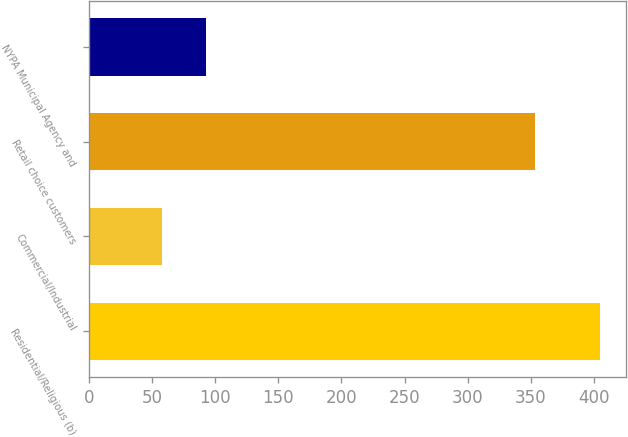Convert chart to OTSL. <chart><loc_0><loc_0><loc_500><loc_500><bar_chart><fcel>Residential/Religious (b)<fcel>Commercial/Industrial<fcel>Retail choice customers<fcel>NYPA Municipal Agency and<nl><fcel>405<fcel>58<fcel>353<fcel>92.7<nl></chart> 